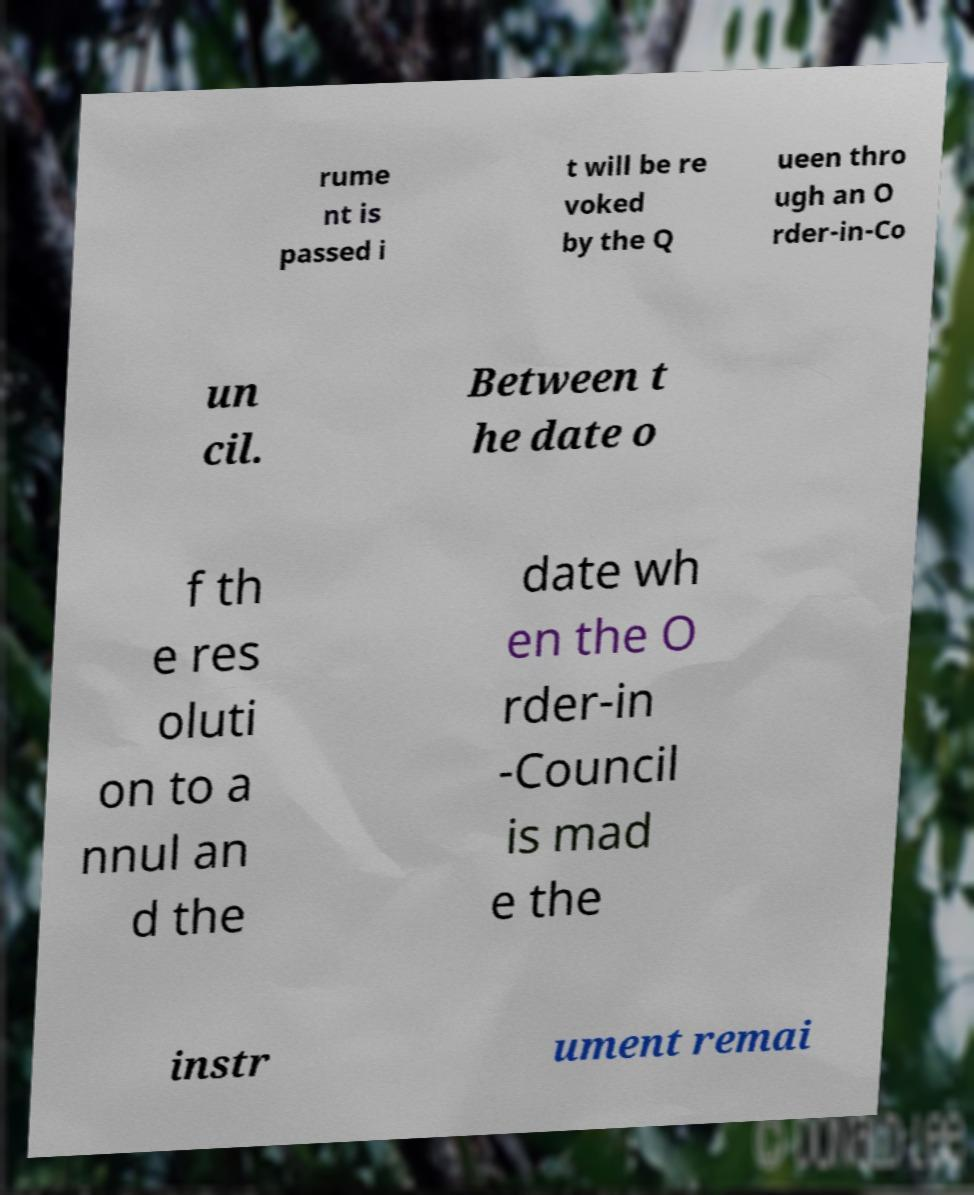Can you read and provide the text displayed in the image?This photo seems to have some interesting text. Can you extract and type it out for me? rume nt is passed i t will be re voked by the Q ueen thro ugh an O rder-in-Co un cil. Between t he date o f th e res oluti on to a nnul an d the date wh en the O rder-in -Council is mad e the instr ument remai 